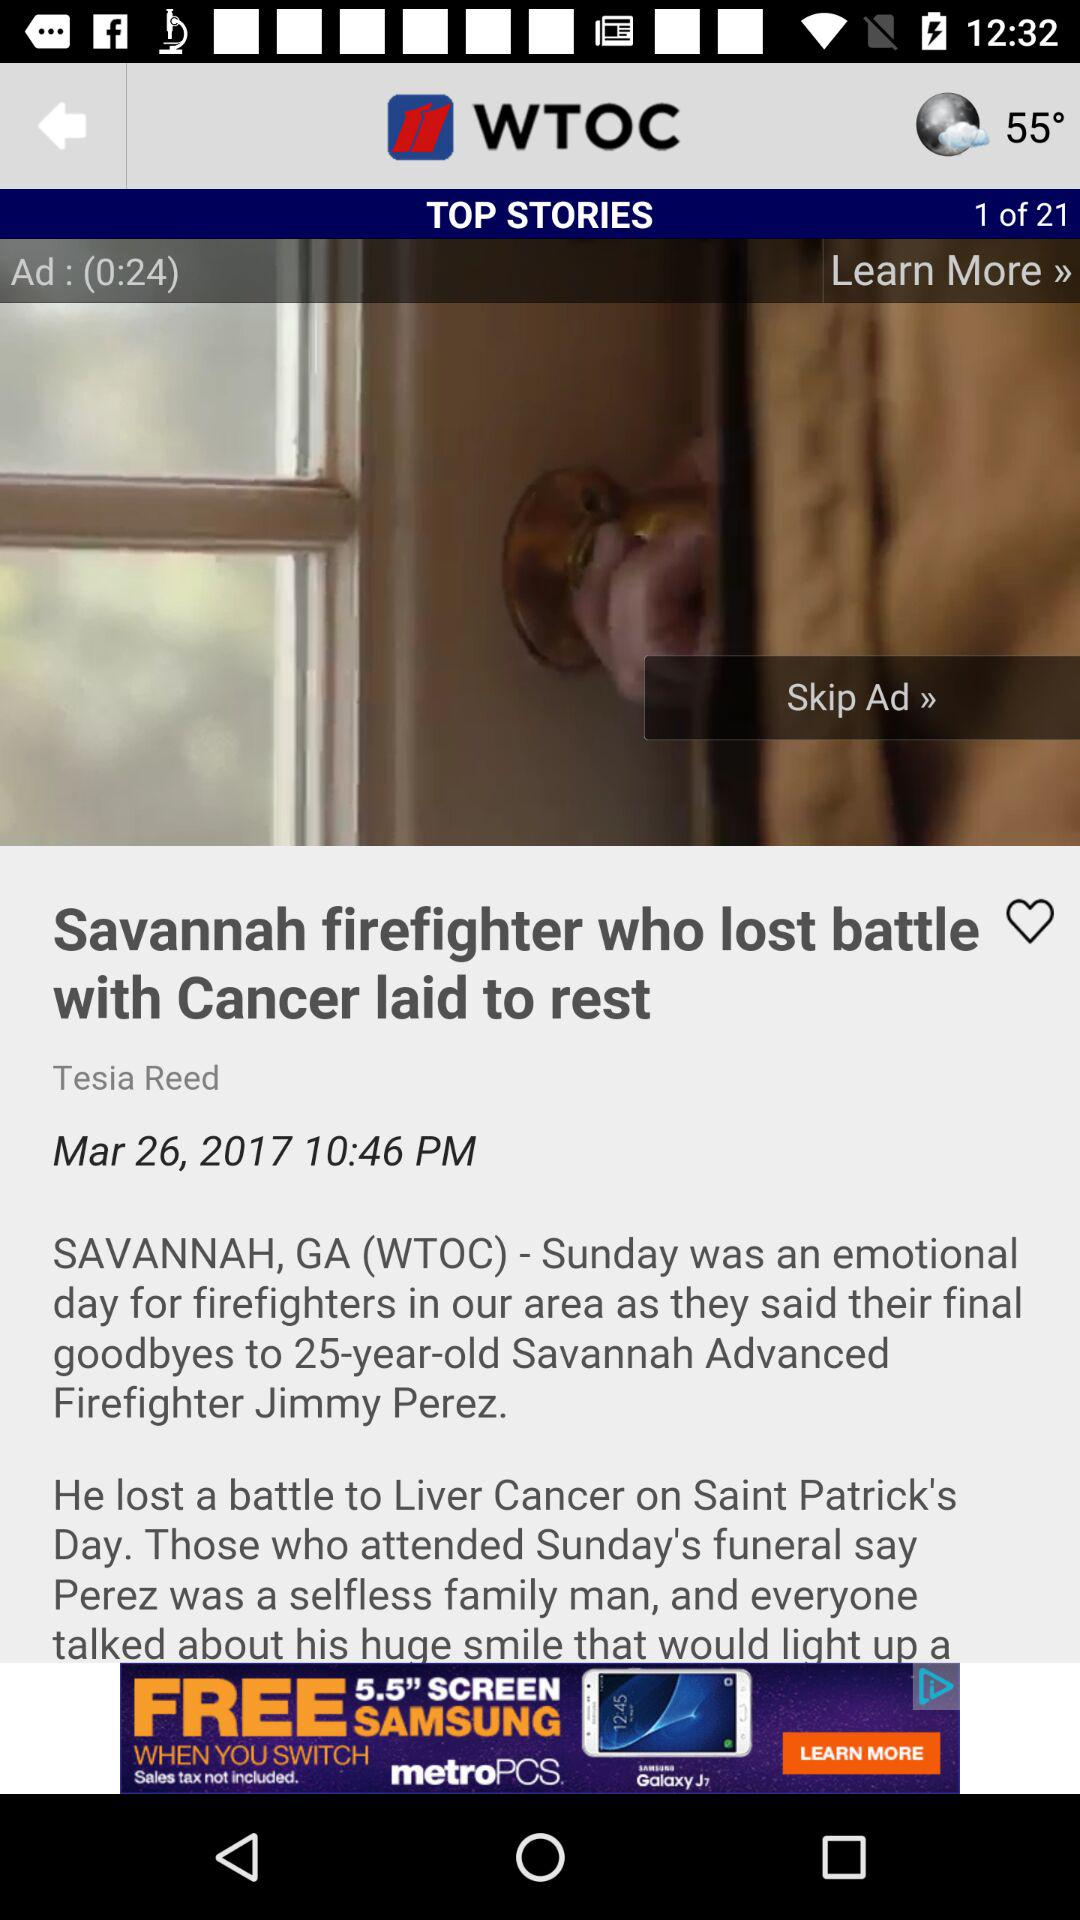Who is the author of this article? The author is Tesla Reed. 